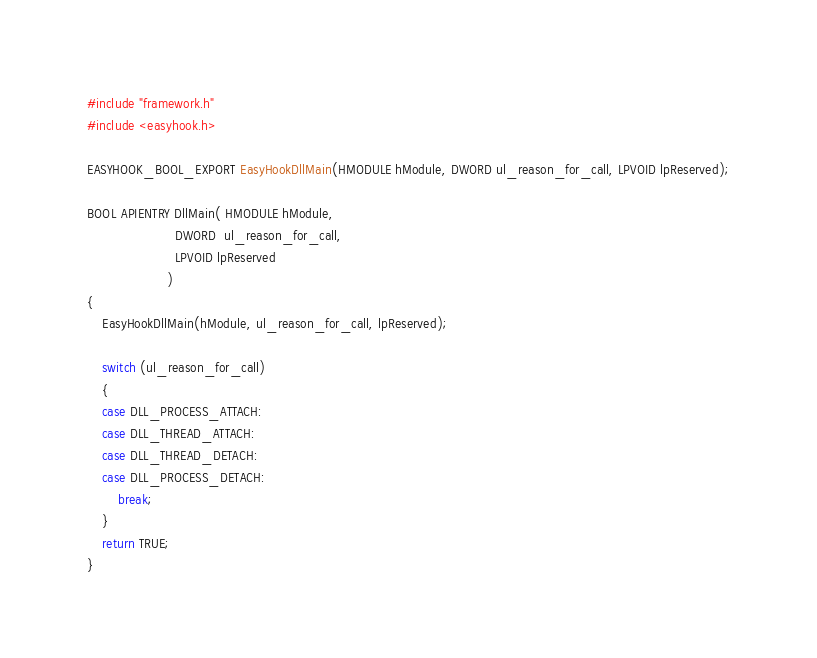Convert code to text. <code><loc_0><loc_0><loc_500><loc_500><_C++_>#include "framework.h"
#include <easyhook.h>

EASYHOOK_BOOL_EXPORT EasyHookDllMain(HMODULE hModule, DWORD ul_reason_for_call, LPVOID lpReserved);

BOOL APIENTRY DllMain( HMODULE hModule,
                       DWORD  ul_reason_for_call,
                       LPVOID lpReserved
                     )
{
    EasyHookDllMain(hModule, ul_reason_for_call, lpReserved);
    	
    switch (ul_reason_for_call)
    {
    case DLL_PROCESS_ATTACH:
    case DLL_THREAD_ATTACH:
    case DLL_THREAD_DETACH:
    case DLL_PROCESS_DETACH:
        break;
    }
    return TRUE;
}

</code> 